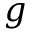Convert formula to latex. <formula><loc_0><loc_0><loc_500><loc_500>g</formula> 